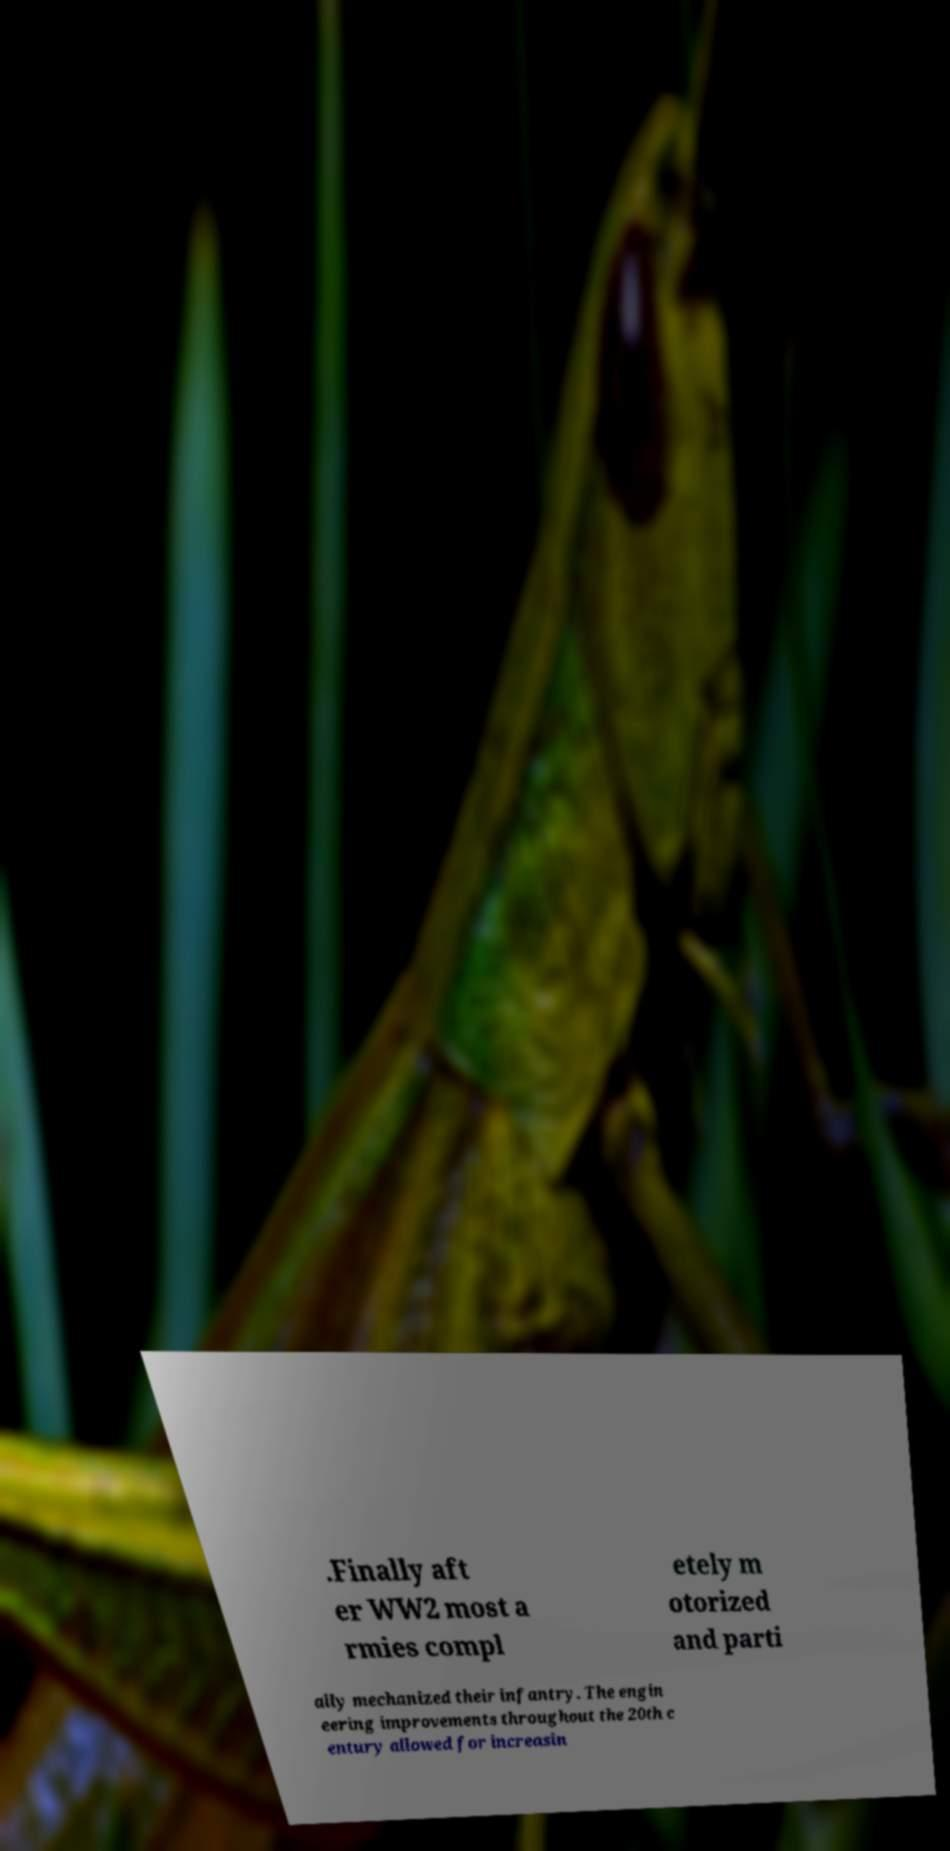There's text embedded in this image that I need extracted. Can you transcribe it verbatim? .Finally aft er WW2 most a rmies compl etely m otorized and parti ally mechanized their infantry. The engin eering improvements throughout the 20th c entury allowed for increasin 